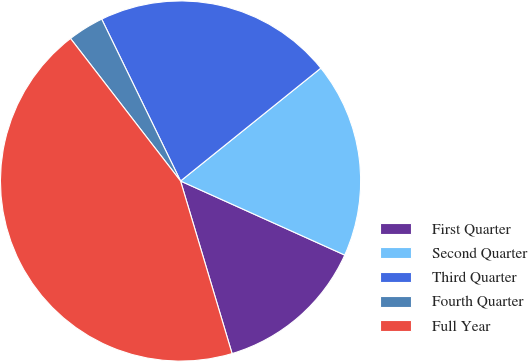Convert chart. <chart><loc_0><loc_0><loc_500><loc_500><pie_chart><fcel>First Quarter<fcel>Second Quarter<fcel>Third Quarter<fcel>Fourth Quarter<fcel>Full Year<nl><fcel>13.64%<fcel>17.53%<fcel>21.43%<fcel>3.25%<fcel>44.16%<nl></chart> 